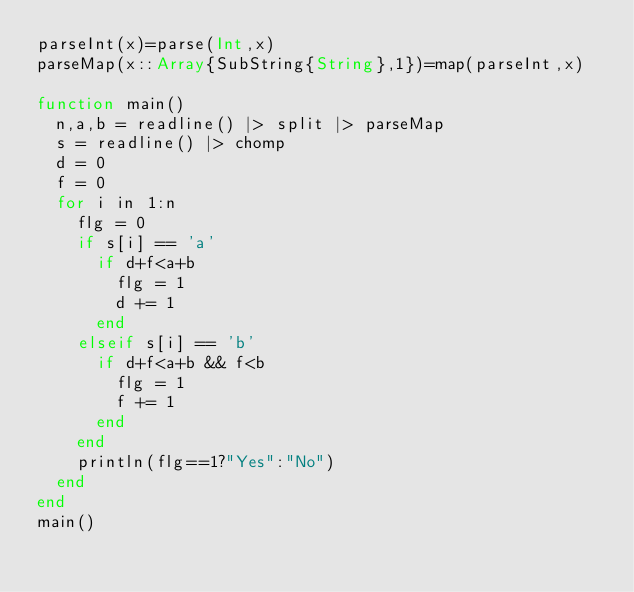Convert code to text. <code><loc_0><loc_0><loc_500><loc_500><_Julia_>parseInt(x)=parse(Int,x)
parseMap(x::Array{SubString{String},1})=map(parseInt,x)

function main()
	n,a,b = readline() |> split |> parseMap
	s = readline() |> chomp
	d = 0
	f = 0
	for i in 1:n
		flg = 0
		if s[i] == 'a'
			if d+f<a+b
				flg = 1
				d += 1
			end
		elseif s[i] == 'b'
			if d+f<a+b && f<b
				flg = 1
				f += 1
			end
		end
		println(flg==1?"Yes":"No")
	end
end
main()
</code> 